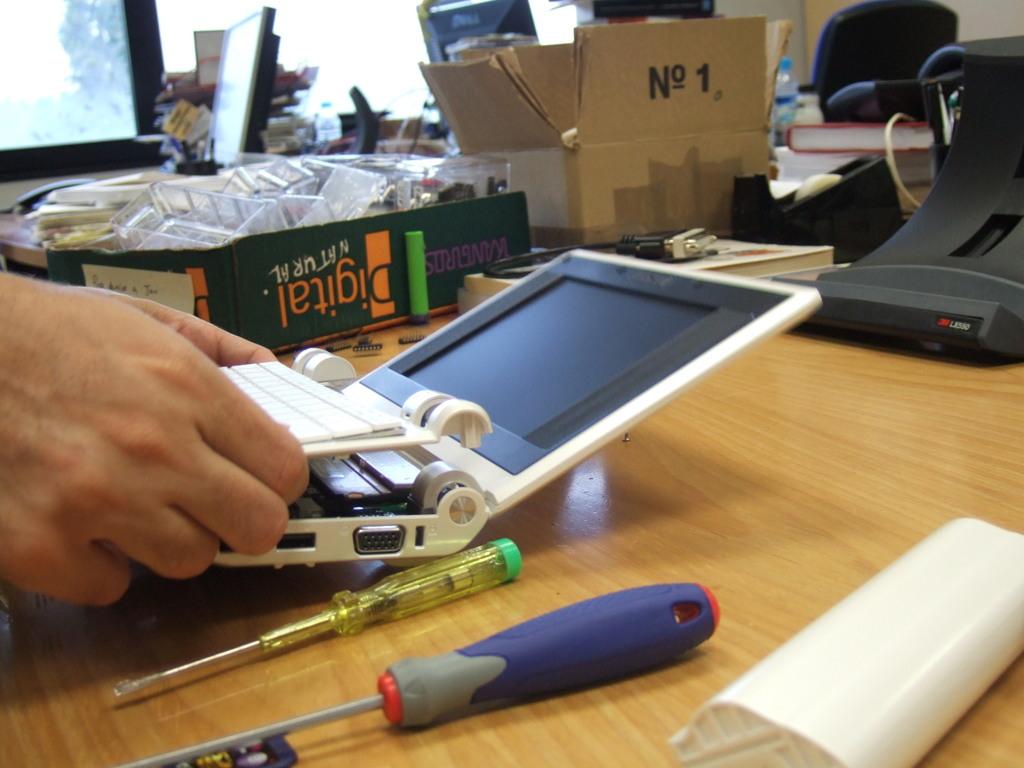What no is shown?
Your response must be concise. 1. 